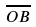<formula> <loc_0><loc_0><loc_500><loc_500>\overline { O B }</formula> 